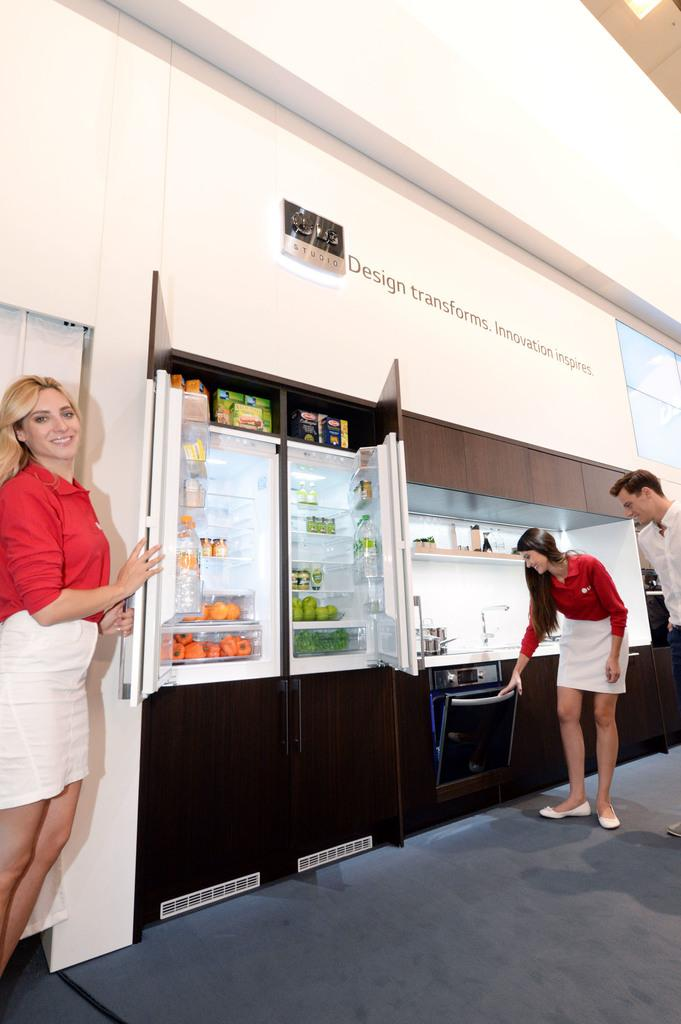<image>
Render a clear and concise summary of the photo. A kitchen display below a tagline about design and innovation. 